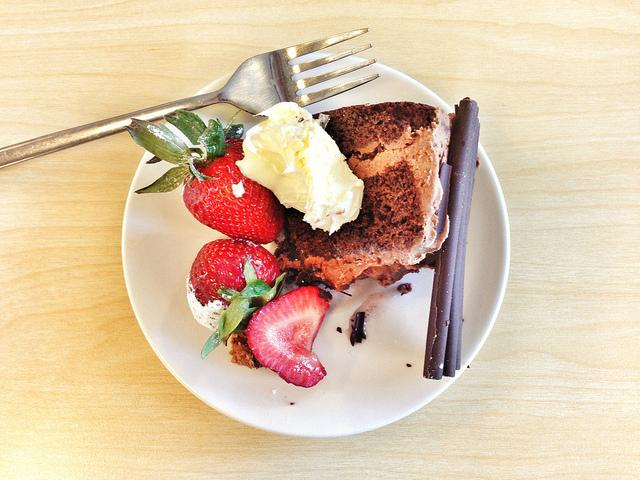What kind of fruit is there a serving of to the side of the cake?

Choices:
A) raspberry
B) strawbery
C) pineapple
D) grapefruit strawbery 